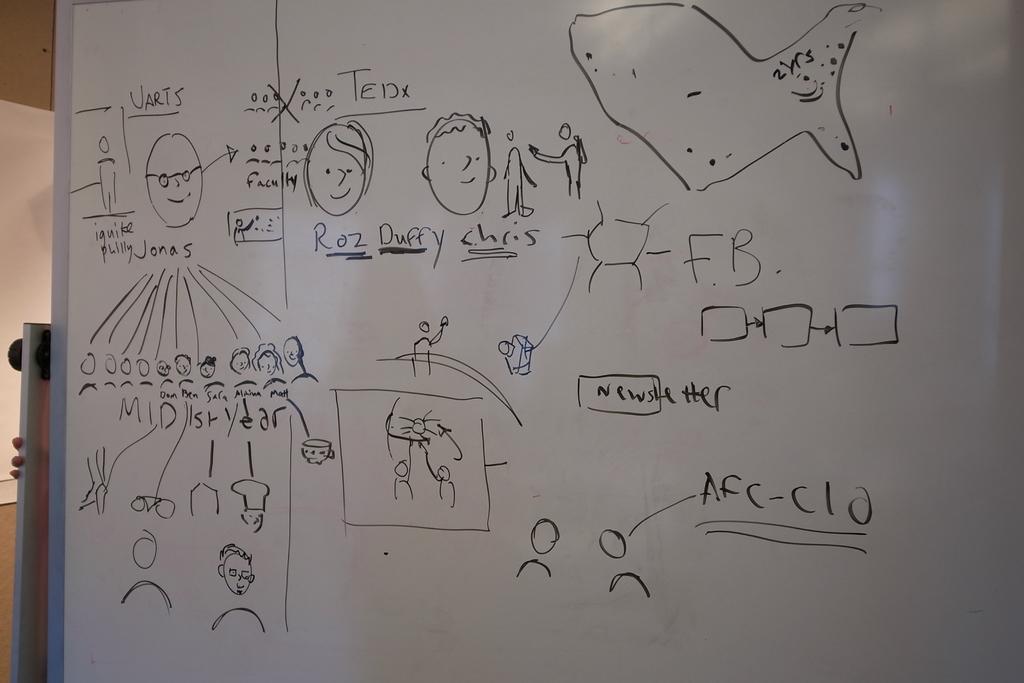What is the name of the character drawn to the left of duffy?
Ensure brevity in your answer.  Roz. 